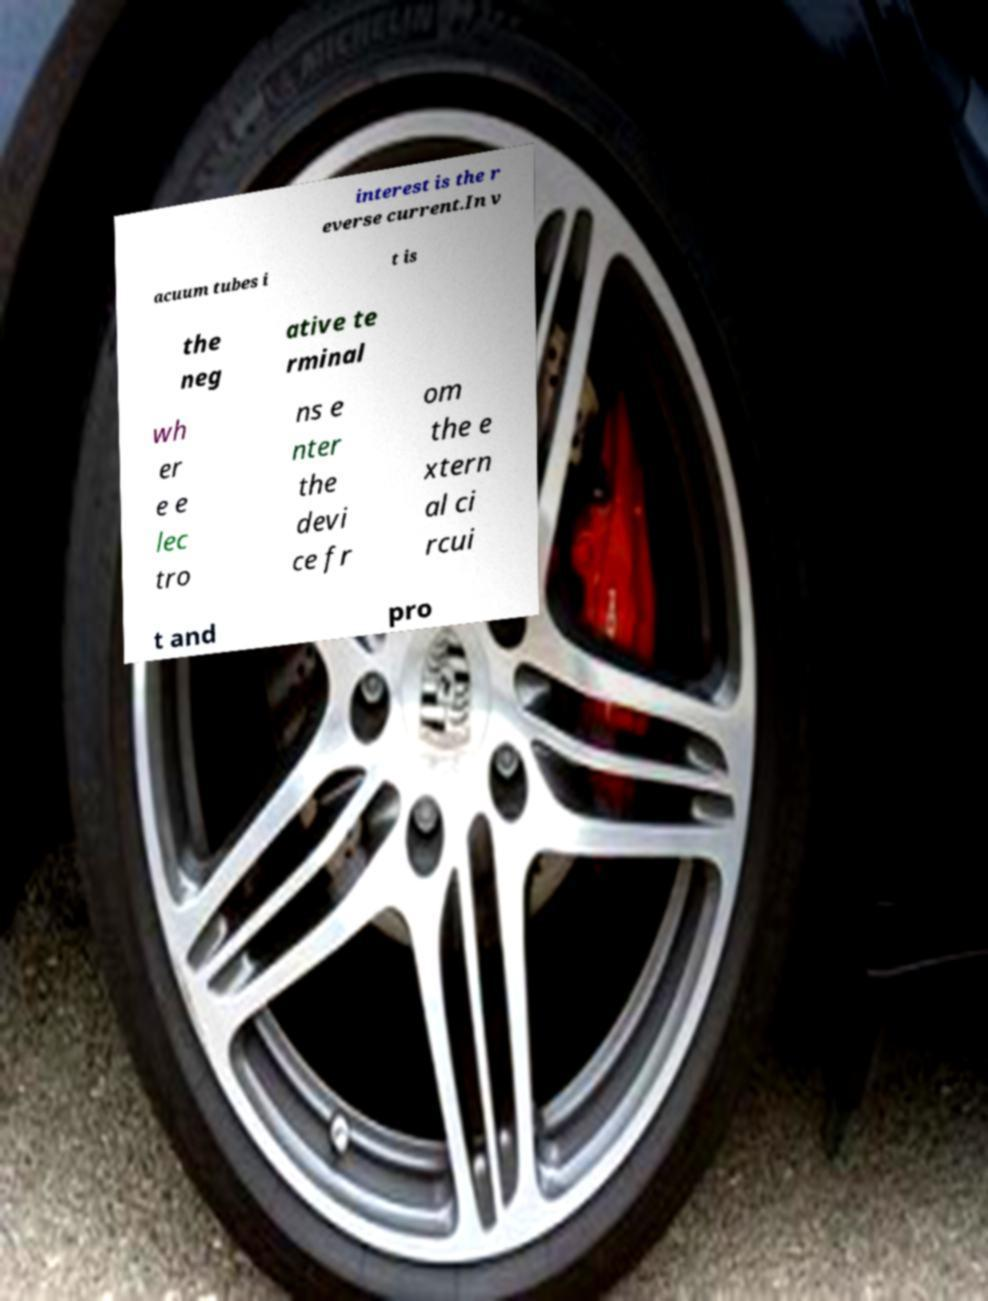Could you extract and type out the text from this image? interest is the r everse current.In v acuum tubes i t is the neg ative te rminal wh er e e lec tro ns e nter the devi ce fr om the e xtern al ci rcui t and pro 